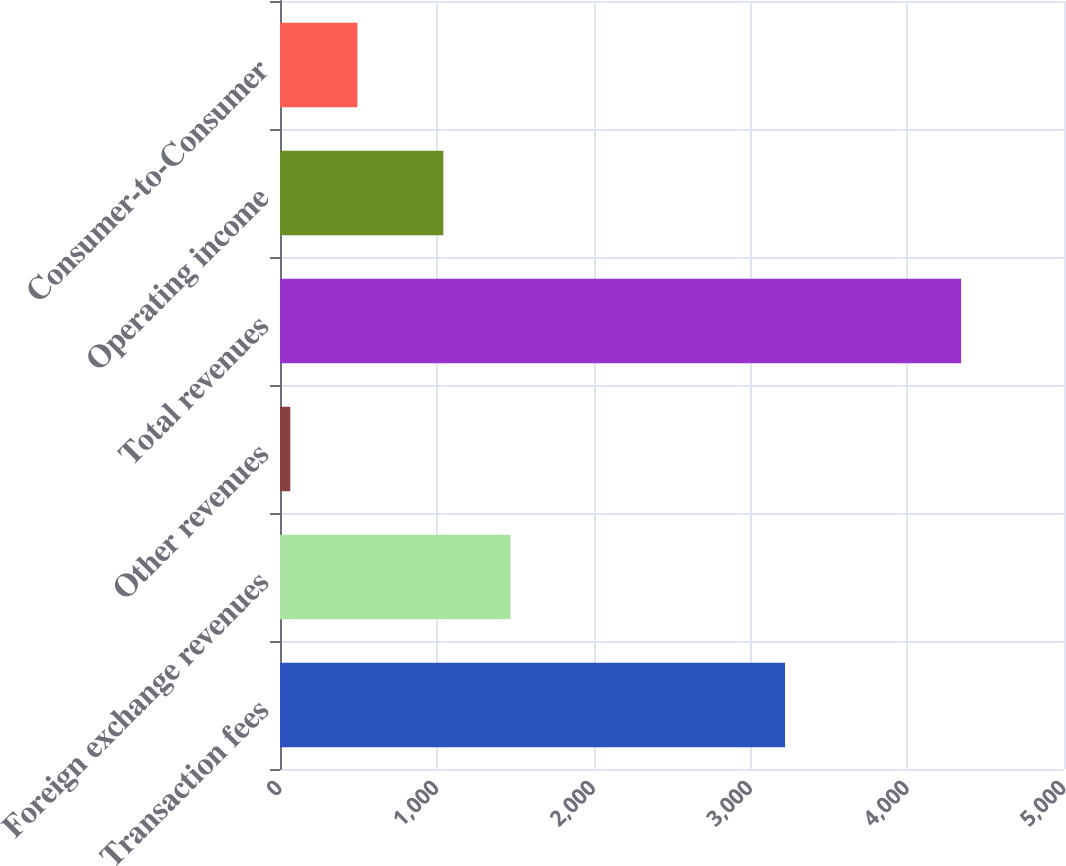Convert chart. <chart><loc_0><loc_0><loc_500><loc_500><bar_chart><fcel>Transaction fees<fcel>Foreign exchange revenues<fcel>Other revenues<fcel>Total revenues<fcel>Operating income<fcel>Consumer-to-Consumer<nl><fcel>3221<fcel>1469.81<fcel>65.8<fcel>4343.9<fcel>1042<fcel>493.61<nl></chart> 